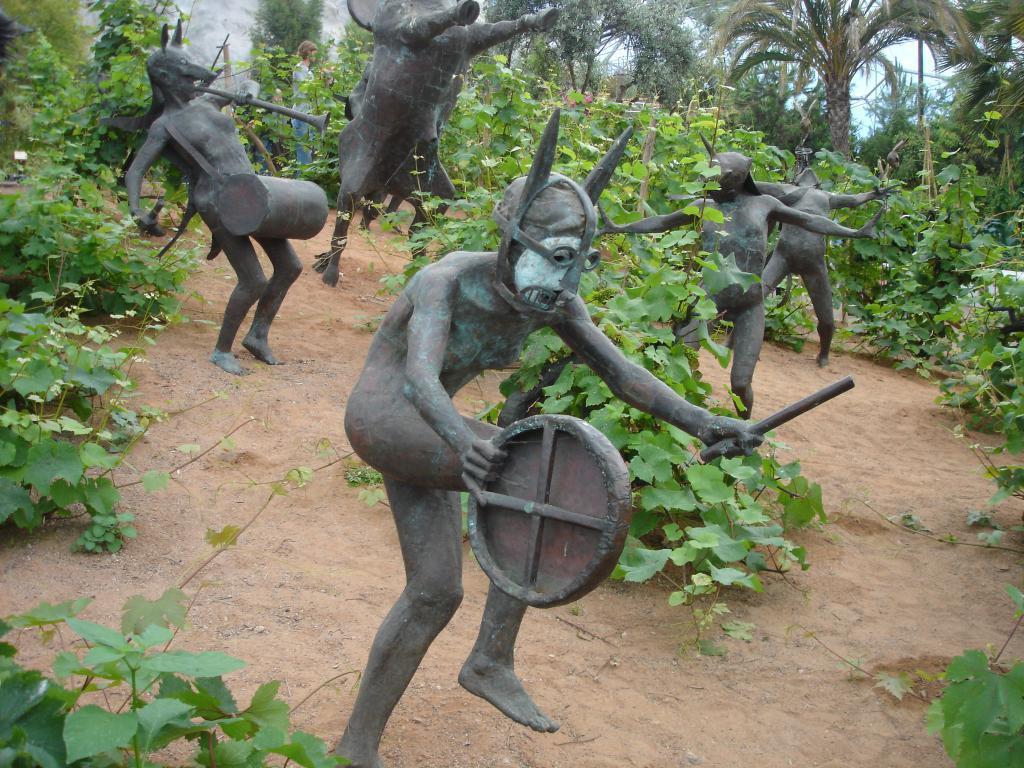In one or two sentences, can you explain what this image depicts? In this image we can see statues,plants. In the background of the image there are trees. 